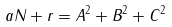Convert formula to latex. <formula><loc_0><loc_0><loc_500><loc_500>a N + r = A ^ { 2 } + B ^ { 2 } + C ^ { 2 }</formula> 